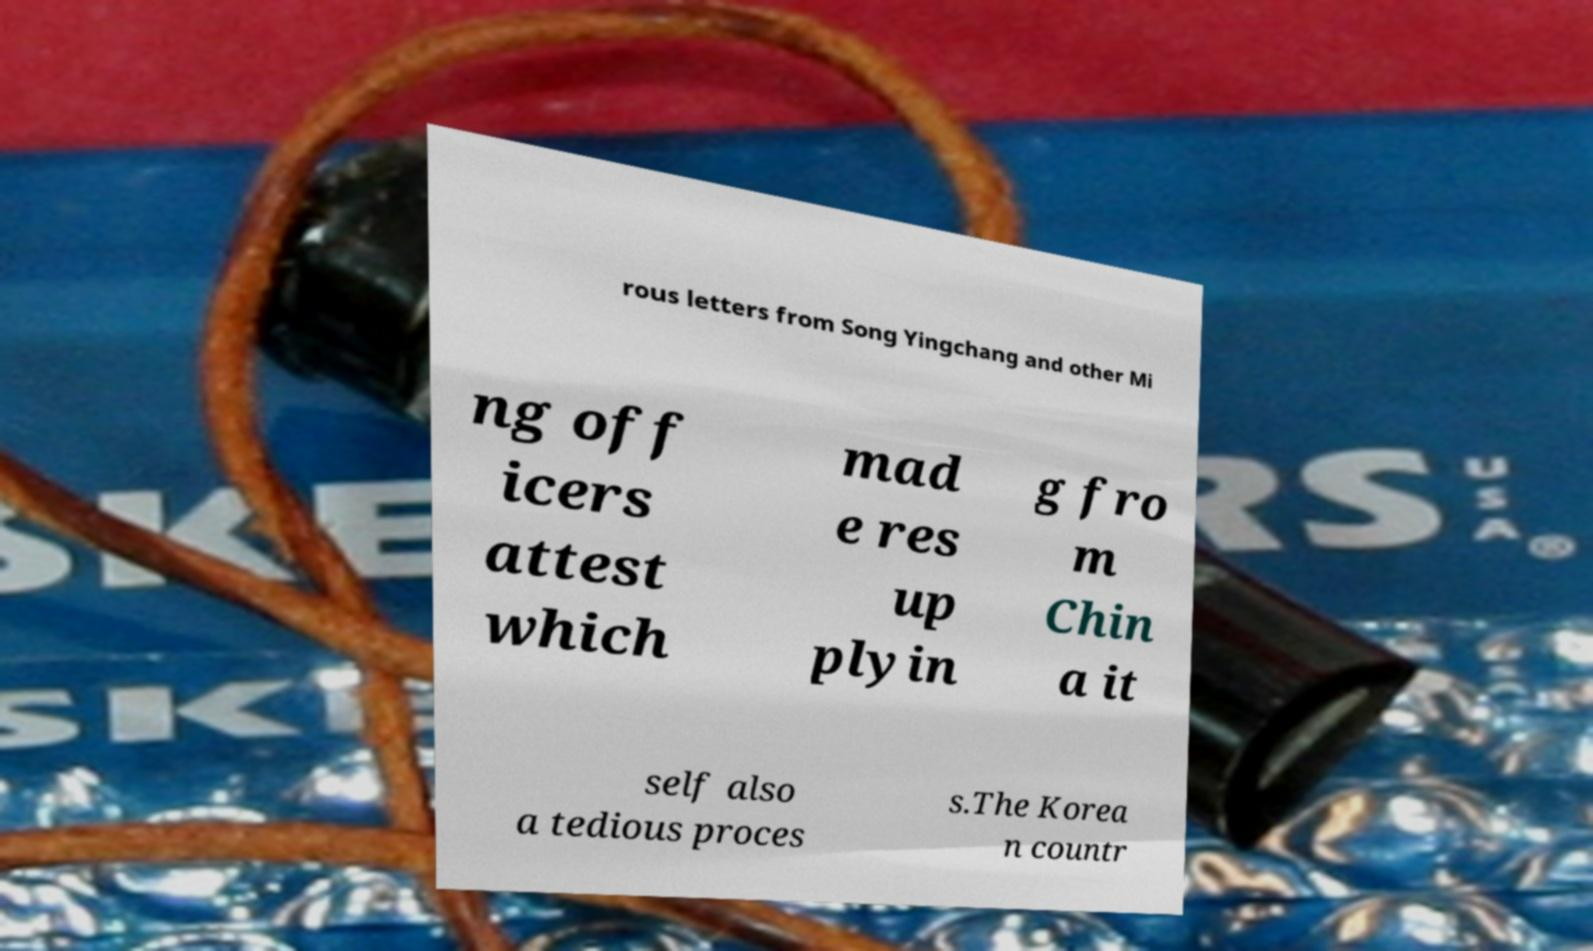Can you read and provide the text displayed in the image?This photo seems to have some interesting text. Can you extract and type it out for me? rous letters from Song Yingchang and other Mi ng off icers attest which mad e res up plyin g fro m Chin a it self also a tedious proces s.The Korea n countr 